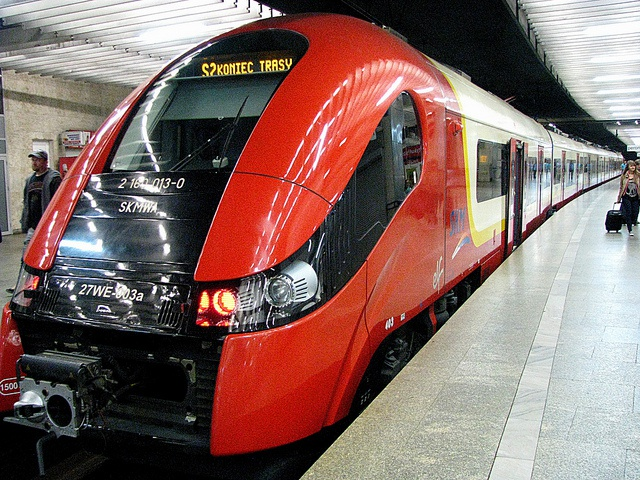Describe the objects in this image and their specific colors. I can see train in lightgray, black, red, brown, and gray tones, people in lightgray, black, gray, darkgray, and maroon tones, people in lightgray, black, gray, brown, and darkgray tones, suitcase in lightgray, black, white, navy, and purple tones, and people in lightgray, gray, lightblue, and maroon tones in this image. 